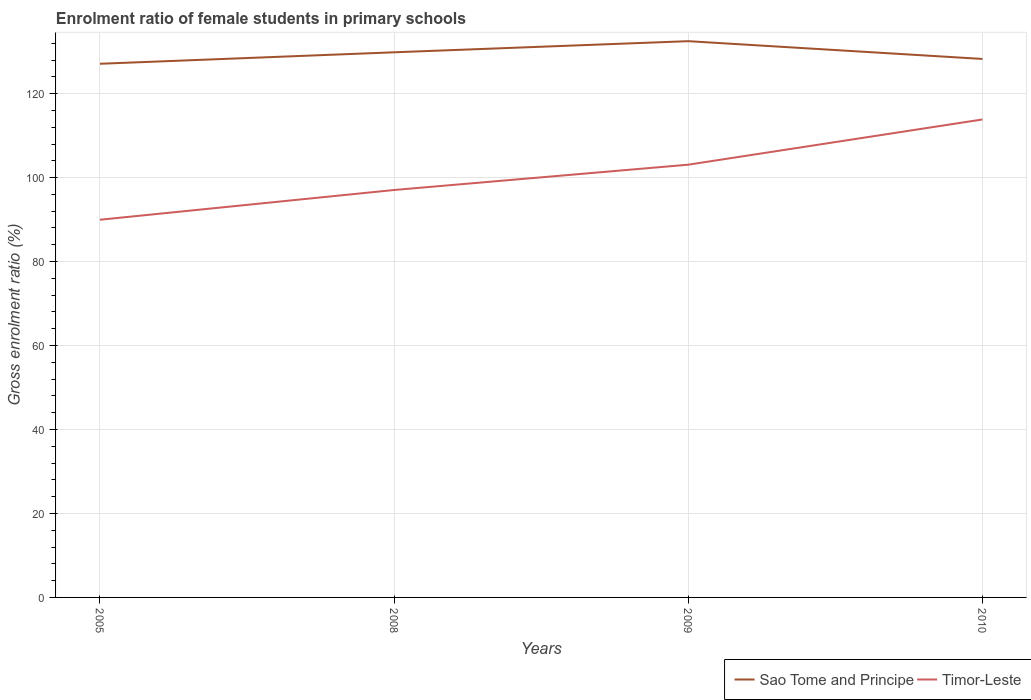How many different coloured lines are there?
Ensure brevity in your answer.  2. Does the line corresponding to Timor-Leste intersect with the line corresponding to Sao Tome and Principe?
Give a very brief answer. No. Across all years, what is the maximum enrolment ratio of female students in primary schools in Timor-Leste?
Your answer should be compact. 89.97. What is the total enrolment ratio of female students in primary schools in Sao Tome and Principe in the graph?
Your response must be concise. -5.38. What is the difference between the highest and the second highest enrolment ratio of female students in primary schools in Sao Tome and Principe?
Your response must be concise. 5.38. How many years are there in the graph?
Your answer should be compact. 4. Are the values on the major ticks of Y-axis written in scientific E-notation?
Provide a short and direct response. No. How many legend labels are there?
Offer a very short reply. 2. How are the legend labels stacked?
Make the answer very short. Horizontal. What is the title of the graph?
Give a very brief answer. Enrolment ratio of female students in primary schools. What is the Gross enrolment ratio (%) in Sao Tome and Principe in 2005?
Offer a very short reply. 127.12. What is the Gross enrolment ratio (%) of Timor-Leste in 2005?
Your response must be concise. 89.97. What is the Gross enrolment ratio (%) of Sao Tome and Principe in 2008?
Provide a succinct answer. 129.85. What is the Gross enrolment ratio (%) of Timor-Leste in 2008?
Offer a very short reply. 97.05. What is the Gross enrolment ratio (%) in Sao Tome and Principe in 2009?
Your answer should be compact. 132.5. What is the Gross enrolment ratio (%) in Timor-Leste in 2009?
Provide a short and direct response. 103.08. What is the Gross enrolment ratio (%) of Sao Tome and Principe in 2010?
Your response must be concise. 128.27. What is the Gross enrolment ratio (%) of Timor-Leste in 2010?
Your answer should be compact. 113.85. Across all years, what is the maximum Gross enrolment ratio (%) in Sao Tome and Principe?
Your answer should be very brief. 132.5. Across all years, what is the maximum Gross enrolment ratio (%) of Timor-Leste?
Your response must be concise. 113.85. Across all years, what is the minimum Gross enrolment ratio (%) of Sao Tome and Principe?
Ensure brevity in your answer.  127.12. Across all years, what is the minimum Gross enrolment ratio (%) in Timor-Leste?
Offer a terse response. 89.97. What is the total Gross enrolment ratio (%) in Sao Tome and Principe in the graph?
Make the answer very short. 517.73. What is the total Gross enrolment ratio (%) of Timor-Leste in the graph?
Ensure brevity in your answer.  403.94. What is the difference between the Gross enrolment ratio (%) in Sao Tome and Principe in 2005 and that in 2008?
Give a very brief answer. -2.73. What is the difference between the Gross enrolment ratio (%) of Timor-Leste in 2005 and that in 2008?
Your answer should be compact. -7.08. What is the difference between the Gross enrolment ratio (%) in Sao Tome and Principe in 2005 and that in 2009?
Provide a short and direct response. -5.38. What is the difference between the Gross enrolment ratio (%) of Timor-Leste in 2005 and that in 2009?
Your answer should be compact. -13.11. What is the difference between the Gross enrolment ratio (%) of Sao Tome and Principe in 2005 and that in 2010?
Your answer should be compact. -1.15. What is the difference between the Gross enrolment ratio (%) in Timor-Leste in 2005 and that in 2010?
Your answer should be compact. -23.88. What is the difference between the Gross enrolment ratio (%) of Sao Tome and Principe in 2008 and that in 2009?
Your answer should be very brief. -2.65. What is the difference between the Gross enrolment ratio (%) in Timor-Leste in 2008 and that in 2009?
Provide a succinct answer. -6.03. What is the difference between the Gross enrolment ratio (%) in Sao Tome and Principe in 2008 and that in 2010?
Ensure brevity in your answer.  1.58. What is the difference between the Gross enrolment ratio (%) in Timor-Leste in 2008 and that in 2010?
Give a very brief answer. -16.8. What is the difference between the Gross enrolment ratio (%) in Sao Tome and Principe in 2009 and that in 2010?
Provide a succinct answer. 4.23. What is the difference between the Gross enrolment ratio (%) of Timor-Leste in 2009 and that in 2010?
Ensure brevity in your answer.  -10.77. What is the difference between the Gross enrolment ratio (%) in Sao Tome and Principe in 2005 and the Gross enrolment ratio (%) in Timor-Leste in 2008?
Your answer should be compact. 30.07. What is the difference between the Gross enrolment ratio (%) of Sao Tome and Principe in 2005 and the Gross enrolment ratio (%) of Timor-Leste in 2009?
Offer a very short reply. 24.04. What is the difference between the Gross enrolment ratio (%) of Sao Tome and Principe in 2005 and the Gross enrolment ratio (%) of Timor-Leste in 2010?
Make the answer very short. 13.27. What is the difference between the Gross enrolment ratio (%) in Sao Tome and Principe in 2008 and the Gross enrolment ratio (%) in Timor-Leste in 2009?
Give a very brief answer. 26.77. What is the difference between the Gross enrolment ratio (%) of Sao Tome and Principe in 2008 and the Gross enrolment ratio (%) of Timor-Leste in 2010?
Keep it short and to the point. 16. What is the difference between the Gross enrolment ratio (%) of Sao Tome and Principe in 2009 and the Gross enrolment ratio (%) of Timor-Leste in 2010?
Make the answer very short. 18.65. What is the average Gross enrolment ratio (%) of Sao Tome and Principe per year?
Your response must be concise. 129.43. What is the average Gross enrolment ratio (%) in Timor-Leste per year?
Your answer should be very brief. 100.98. In the year 2005, what is the difference between the Gross enrolment ratio (%) in Sao Tome and Principe and Gross enrolment ratio (%) in Timor-Leste?
Your answer should be compact. 37.15. In the year 2008, what is the difference between the Gross enrolment ratio (%) in Sao Tome and Principe and Gross enrolment ratio (%) in Timor-Leste?
Ensure brevity in your answer.  32.8. In the year 2009, what is the difference between the Gross enrolment ratio (%) of Sao Tome and Principe and Gross enrolment ratio (%) of Timor-Leste?
Provide a short and direct response. 29.42. In the year 2010, what is the difference between the Gross enrolment ratio (%) in Sao Tome and Principe and Gross enrolment ratio (%) in Timor-Leste?
Offer a very short reply. 14.42. What is the ratio of the Gross enrolment ratio (%) of Timor-Leste in 2005 to that in 2008?
Offer a very short reply. 0.93. What is the ratio of the Gross enrolment ratio (%) of Sao Tome and Principe in 2005 to that in 2009?
Give a very brief answer. 0.96. What is the ratio of the Gross enrolment ratio (%) of Timor-Leste in 2005 to that in 2009?
Your answer should be compact. 0.87. What is the ratio of the Gross enrolment ratio (%) of Sao Tome and Principe in 2005 to that in 2010?
Your response must be concise. 0.99. What is the ratio of the Gross enrolment ratio (%) in Timor-Leste in 2005 to that in 2010?
Give a very brief answer. 0.79. What is the ratio of the Gross enrolment ratio (%) in Timor-Leste in 2008 to that in 2009?
Your answer should be very brief. 0.94. What is the ratio of the Gross enrolment ratio (%) of Sao Tome and Principe in 2008 to that in 2010?
Your response must be concise. 1.01. What is the ratio of the Gross enrolment ratio (%) of Timor-Leste in 2008 to that in 2010?
Offer a terse response. 0.85. What is the ratio of the Gross enrolment ratio (%) in Sao Tome and Principe in 2009 to that in 2010?
Offer a very short reply. 1.03. What is the ratio of the Gross enrolment ratio (%) in Timor-Leste in 2009 to that in 2010?
Keep it short and to the point. 0.91. What is the difference between the highest and the second highest Gross enrolment ratio (%) of Sao Tome and Principe?
Your response must be concise. 2.65. What is the difference between the highest and the second highest Gross enrolment ratio (%) in Timor-Leste?
Provide a succinct answer. 10.77. What is the difference between the highest and the lowest Gross enrolment ratio (%) of Sao Tome and Principe?
Keep it short and to the point. 5.38. What is the difference between the highest and the lowest Gross enrolment ratio (%) of Timor-Leste?
Keep it short and to the point. 23.88. 